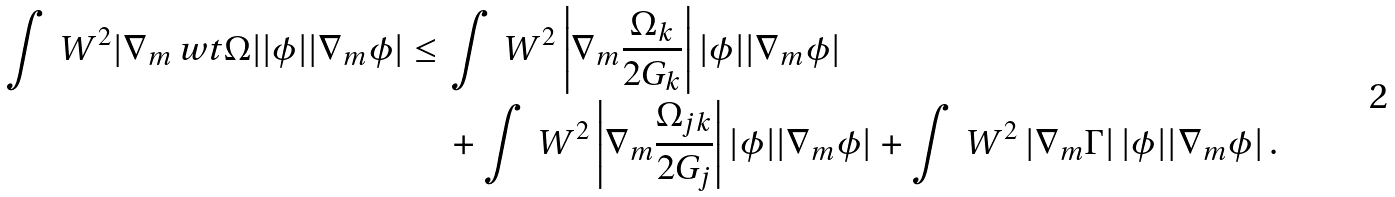<formula> <loc_0><loc_0><loc_500><loc_500>\int \, W ^ { 2 } | \nabla _ { m } \ w t \Omega | | \phi | | \nabla _ { m } \phi | \leq \, & \int \, W ^ { 2 } \left | \nabla _ { m } \frac { \Omega _ { k } } { 2 G _ { k } } \right | | \phi | | \nabla _ { m } \phi | \\ & + \int \, W ^ { 2 } \left | \nabla _ { m } \frac { \Omega _ { j k } } { 2 G _ { j } } \right | | \phi | | \nabla _ { m } \phi | + \int \, W ^ { 2 } \left | \nabla _ { m } \Gamma \right | | \phi | | \nabla _ { m } \phi | \, .</formula> 